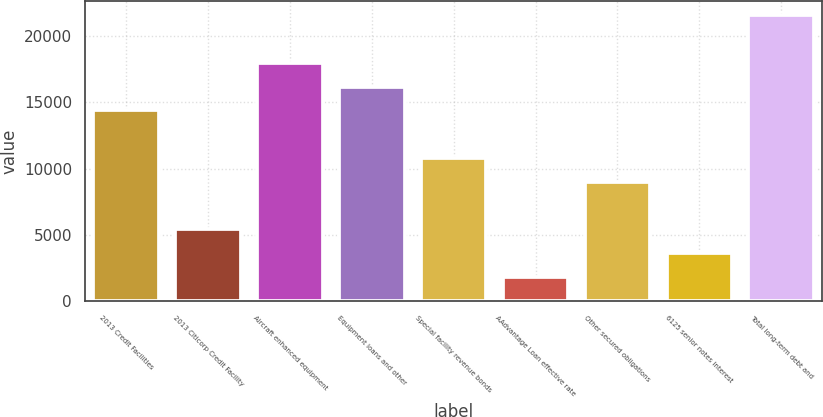<chart> <loc_0><loc_0><loc_500><loc_500><bar_chart><fcel>2013 Credit Facilities<fcel>2013 Citicorp Credit Facility<fcel>Aircraft enhanced equipment<fcel>Equipment loans and other<fcel>Special facility revenue bonds<fcel>AAdvantage Loan effective rate<fcel>Other secured obligations<fcel>6125 senior notes interest<fcel>Total long-term debt and<nl><fcel>14382.2<fcel>5430.2<fcel>17963<fcel>16172.6<fcel>10801.4<fcel>1849.4<fcel>9011<fcel>3639.8<fcel>21543.8<nl></chart> 